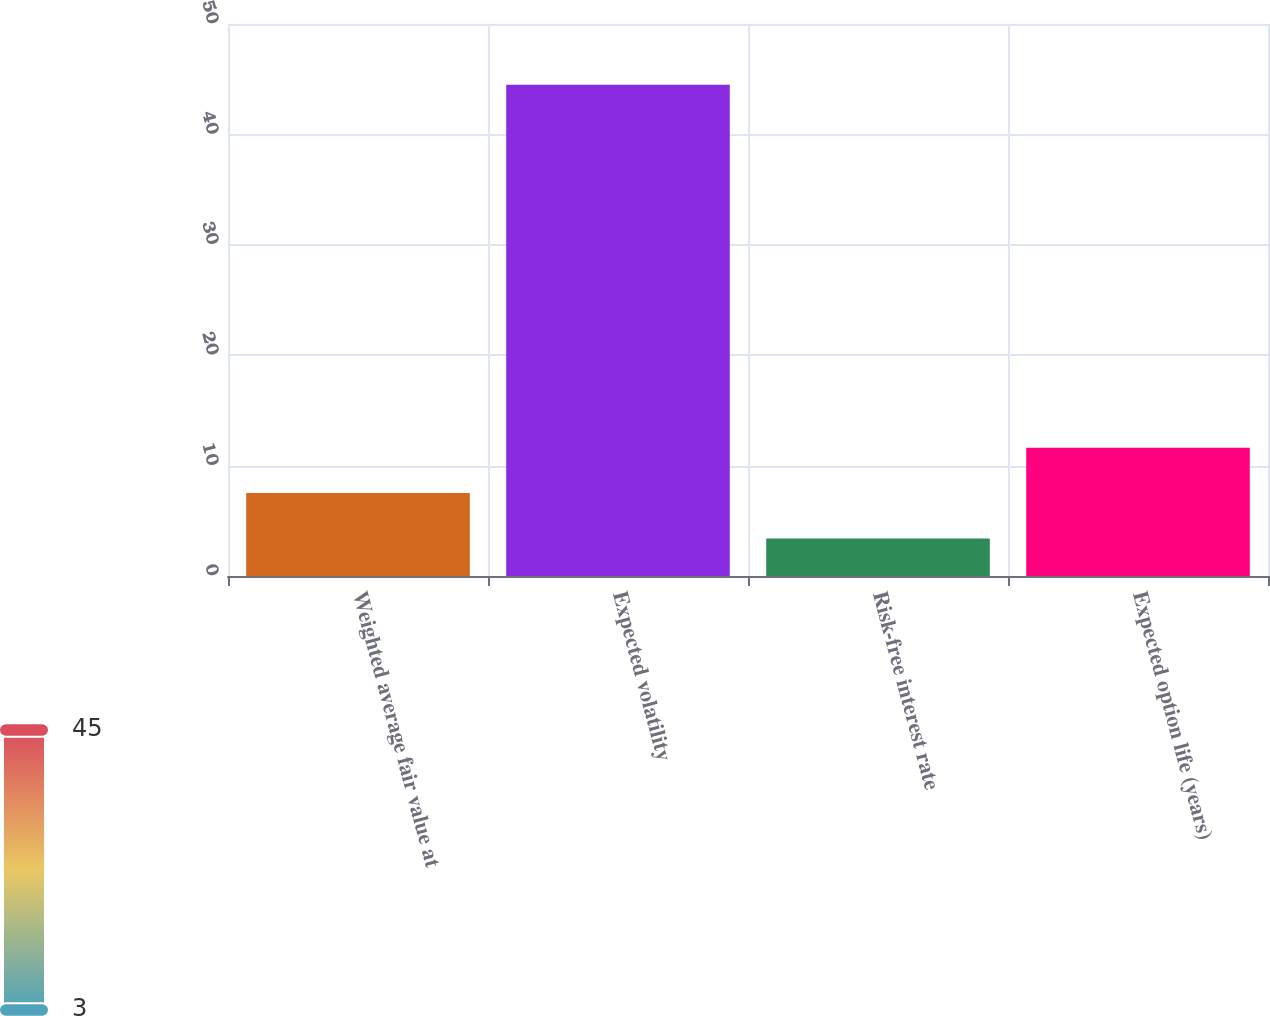<chart> <loc_0><loc_0><loc_500><loc_500><bar_chart><fcel>Weighted average fair value at<fcel>Expected volatility<fcel>Risk-free interest rate<fcel>Expected option life (years)<nl><fcel>7.51<fcel>44.5<fcel>3.4<fcel>11.62<nl></chart> 